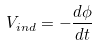<formula> <loc_0><loc_0><loc_500><loc_500>V _ { i n d } = - \frac { d \phi } { d t }</formula> 